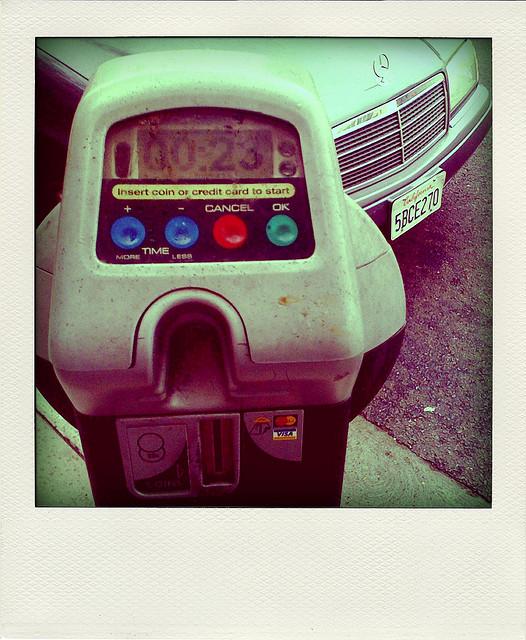What numbers are on the machine?
Answer briefly. 00:23. What is the make of the automobile?
Answer briefly. Mercedes. What is the license plate number?
Concise answer only. 5bce270. 